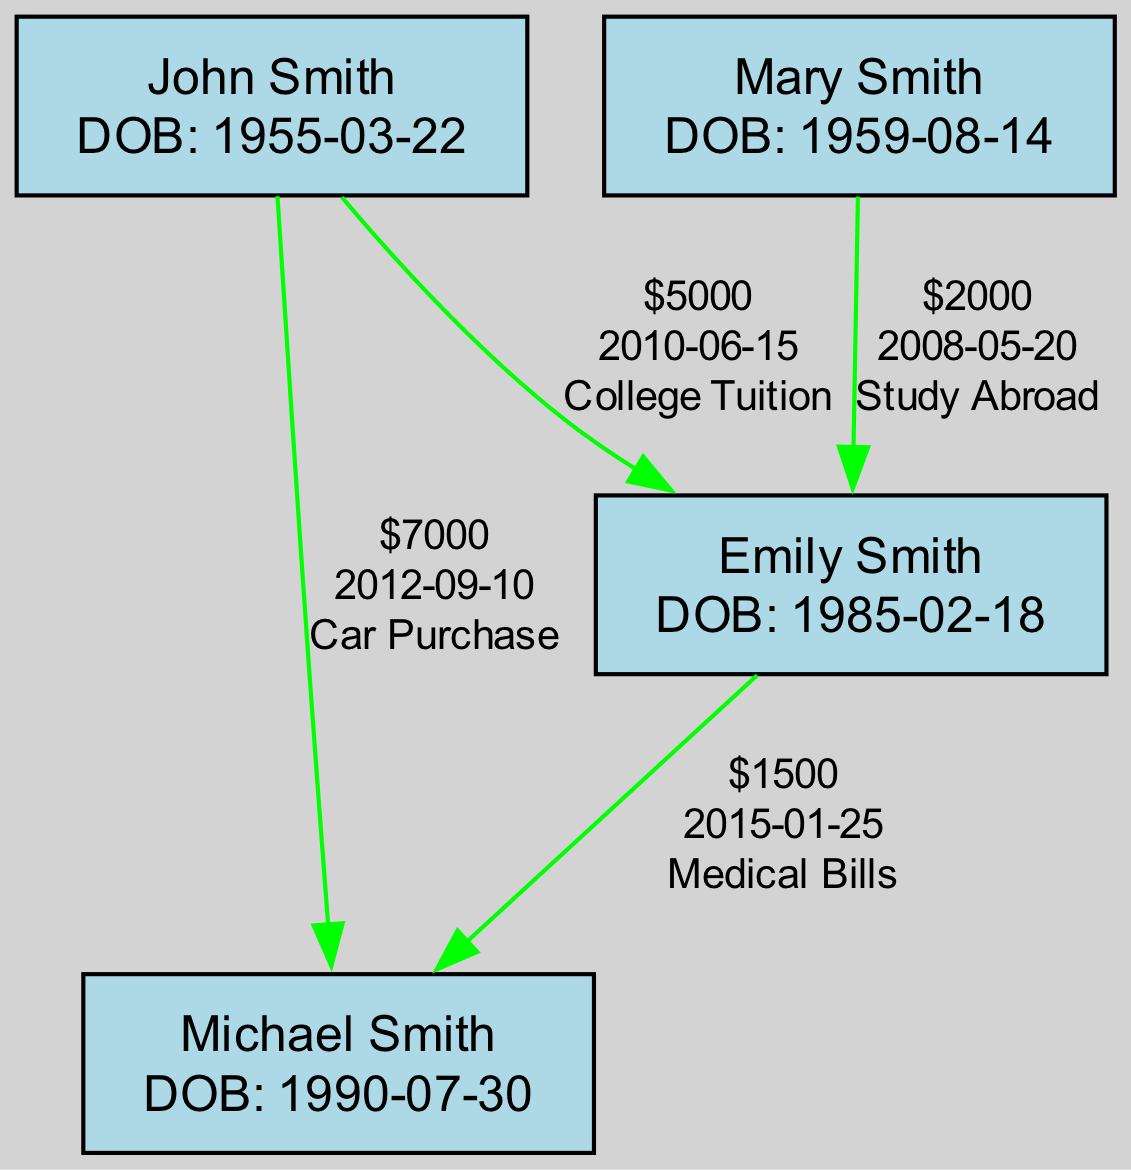What is the total amount of financial assistance given by John Smith? John Smith has given financial assistance to Emily Smith for college tuition ($5000) and Michael Smith for car purchase ($7000). Adding these amounts, we get 5000 + 7000 = 12000.
Answer: 12000 Who received financial assistance from Mary Smith? Mary Smith has given financial assistance only to Emily Smith for studying abroad ($2000). However, she received $3000 from John Smith for home renovation.
Answer: Emily Smith How many financial assistance instances did Michael Smith receive? Michael Smith received financial assistance on two occasions: from John Smith ($7000 for car purchase) and from Emily Smith ($1500 for medical bills). Thus, he has two entries.
Answer: 2 What year did Emily Smith receive assistance for her college tuition? The financial assistance for college tuition was given to Emily Smith by John Smith on June 15, 2010. The year can be found directly in the financial assistance entry for that date.
Answer: 2010 How much total assistance did Emily Smith give to Michael Smith? Emily Smith gave Michael Smith $1500 for medical bills, which represents the total amount she has given to him. There is only one financial assistance entry for this purpose.
Answer: 1500 Which family member has received the most financial assistance? To find who has received the most, consider the amounts: Emily Smith received $5000 for college and $2000 for study abroad, totaling $7000; Michael Smith received $7000 for a car and $1500 for medical bills, totaling $8500. Michael Smith has received more.
Answer: Michael Smith What is the purpose of the financial assistance given by Mary Smith to Emily Smith? The purpose of the financial assistance given by Mary Smith to Emily Smith was for studying abroad. This is specified in the financial assistance entry for that transaction.
Answer: Study Abroad From whom did Michael Smith receive financial assistance on September 10, 2012? On September 10, 2012, Michael Smith received financial assistance from John Smith for the amount of $7000, as documented in the financial assistance records.
Answer: John Smith 